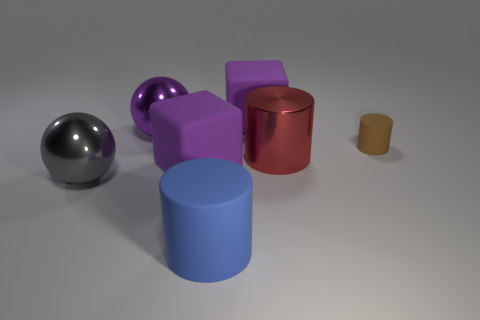Add 2 big blue cylinders. How many objects exist? 9 Subtract all cylinders. How many objects are left? 4 Subtract all tiny green spheres. Subtract all small matte cylinders. How many objects are left? 6 Add 7 brown matte objects. How many brown matte objects are left? 8 Add 5 big gray balls. How many big gray balls exist? 6 Subtract 0 yellow spheres. How many objects are left? 7 